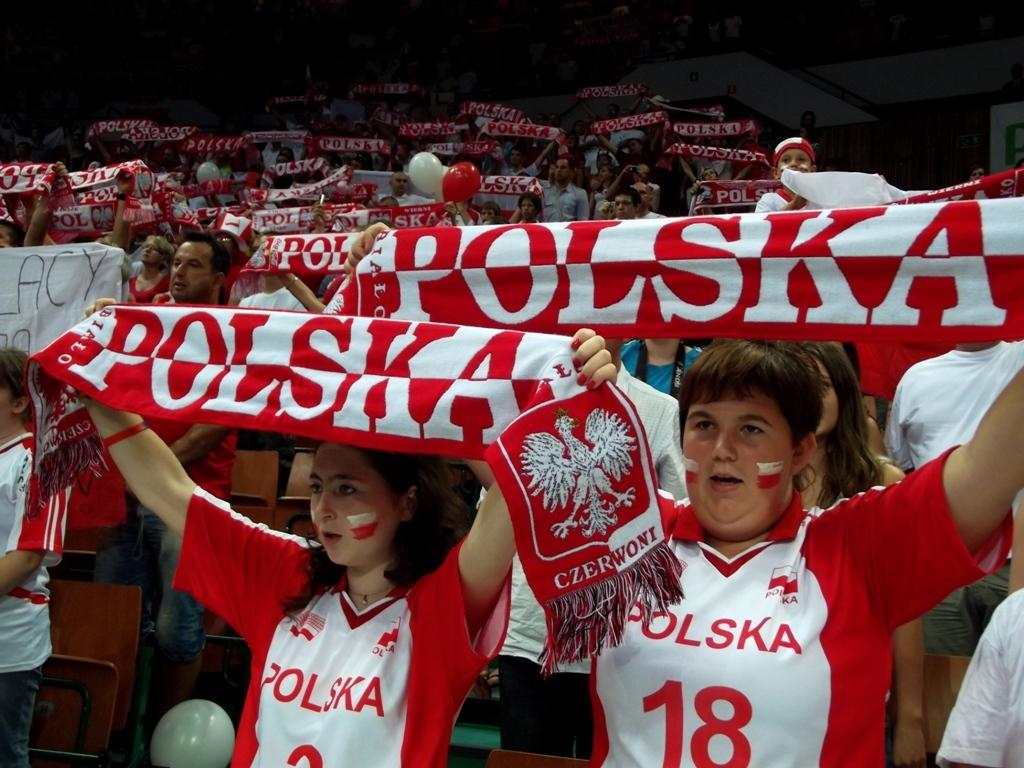How many people are in the image? There are persons in the image. What are the people wearing? The persons are wearing red and white color T-shirts. What are the people doing in the image? The persons are standing. What are the people holding in the image? The persons are holding a cloth. What can be seen on the cloth? There is writing on the cloth. What type of sweater is the volcano wearing in the image? There is no volcano or sweater present in the image. What knowledge can be gained from the image about the persons' educational background? The image does not provide any information about the persons' educational background. 